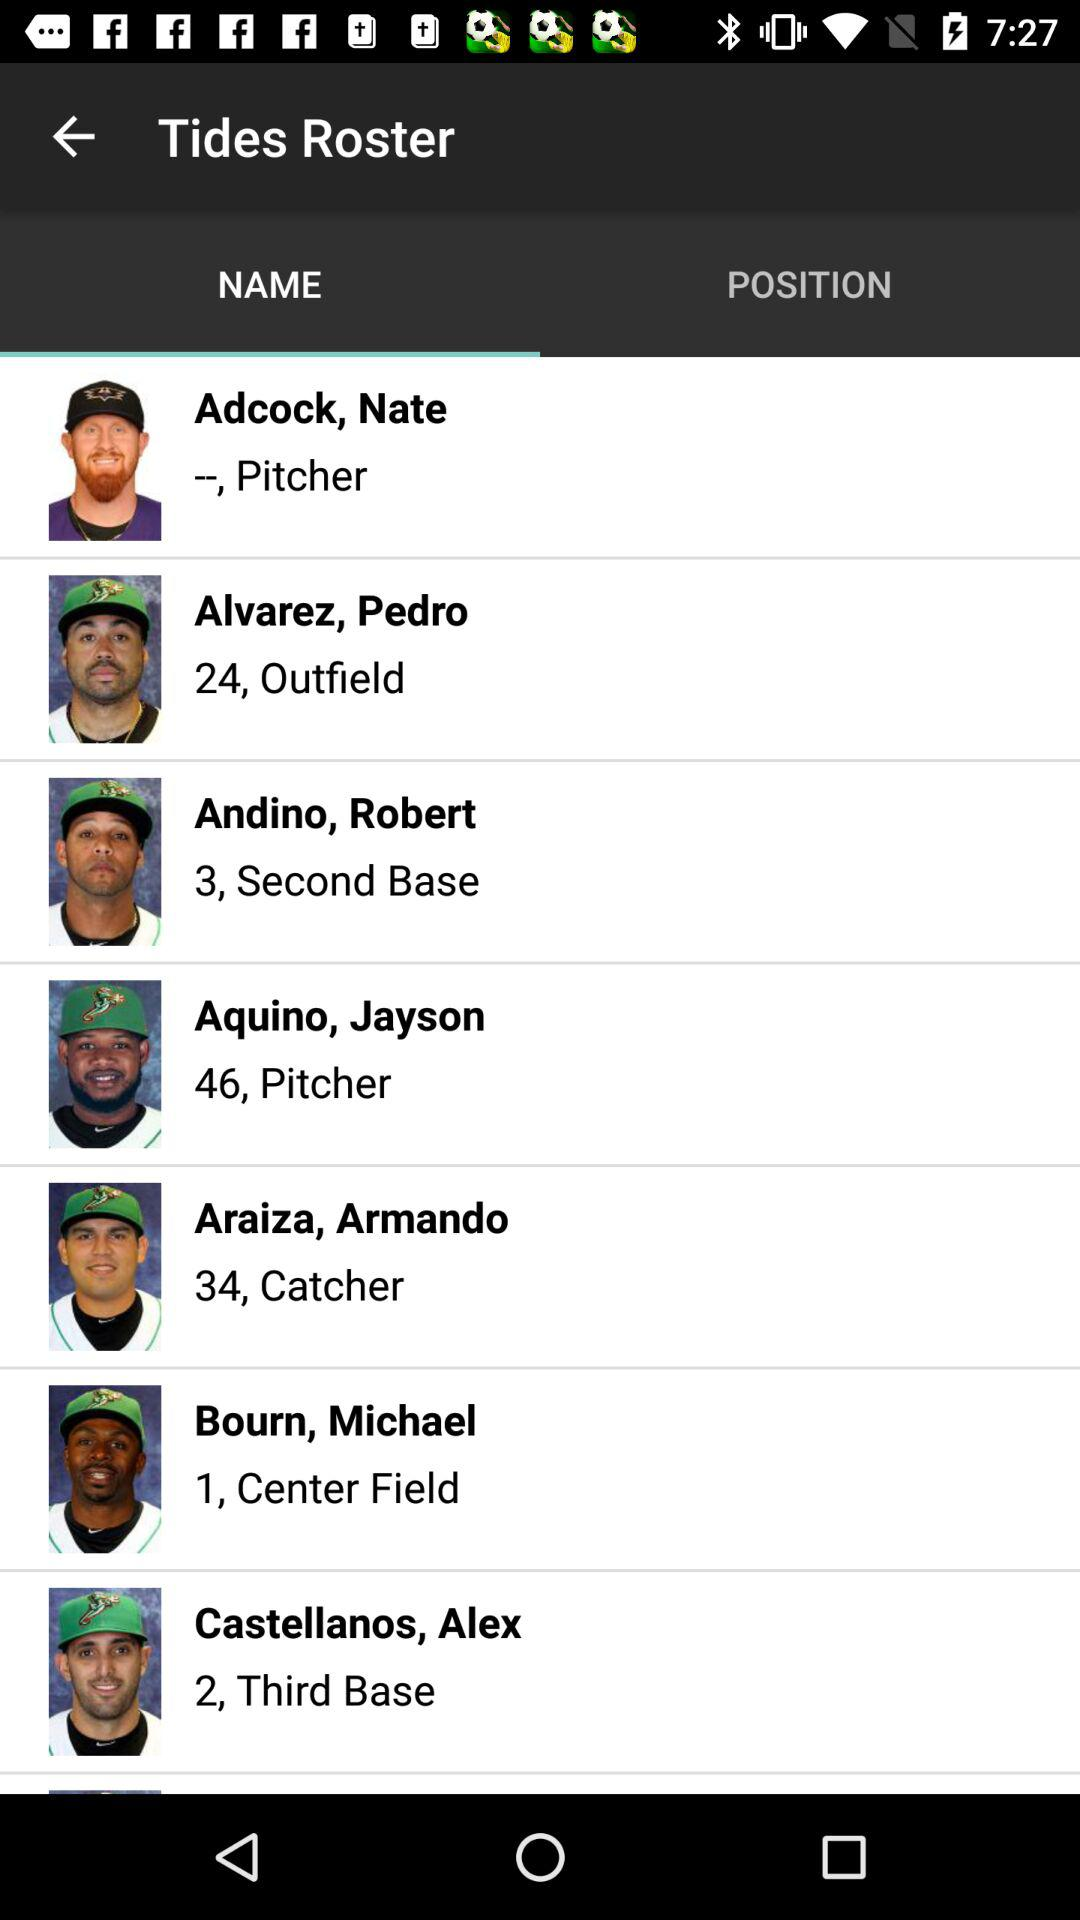What is the name of the catcher? The name of the catcher is Armando Araiza. 